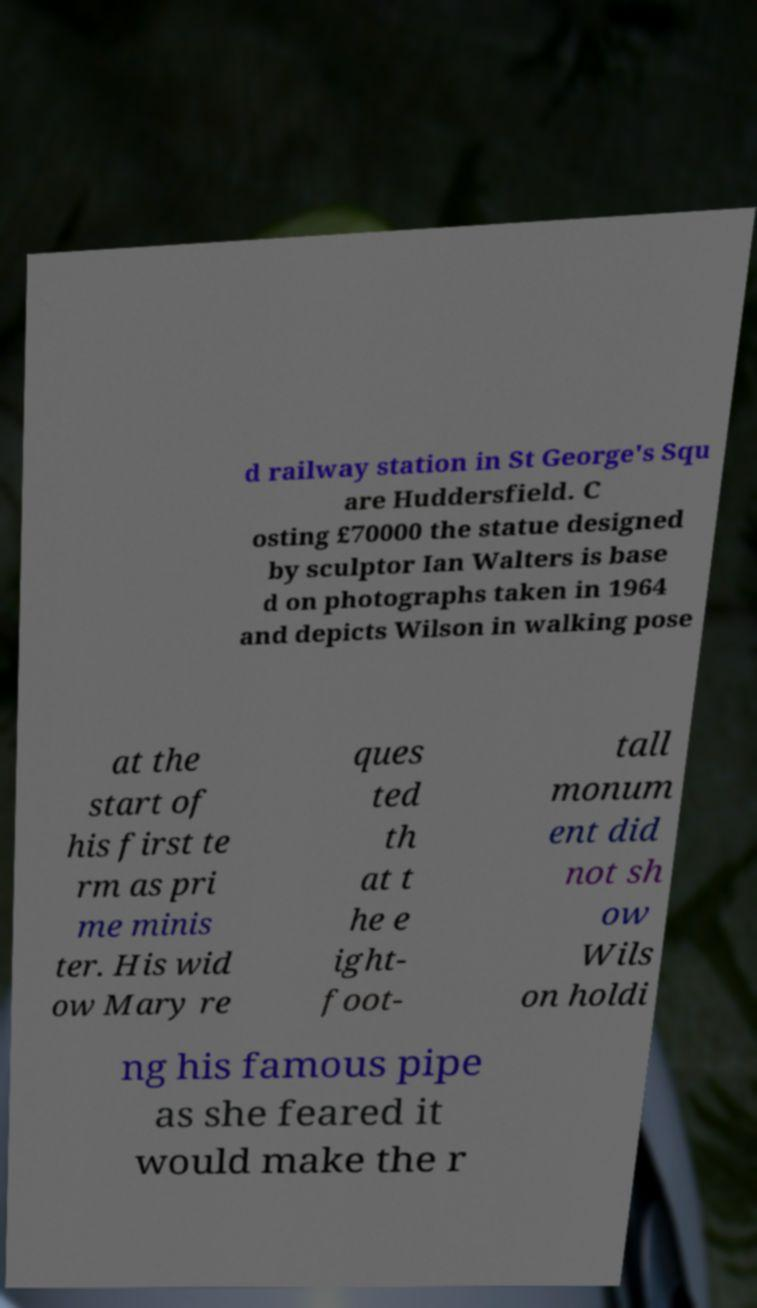What messages or text are displayed in this image? I need them in a readable, typed format. d railway station in St George's Squ are Huddersfield. C osting £70000 the statue designed by sculptor Ian Walters is base d on photographs taken in 1964 and depicts Wilson in walking pose at the start of his first te rm as pri me minis ter. His wid ow Mary re ques ted th at t he e ight- foot- tall monum ent did not sh ow Wils on holdi ng his famous pipe as she feared it would make the r 